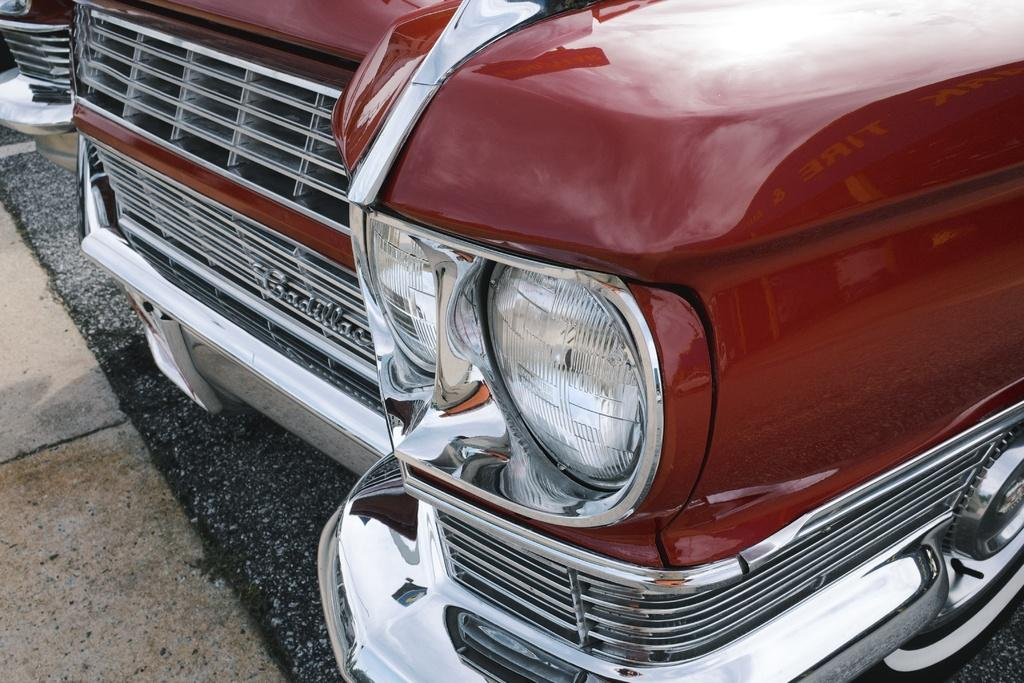What is the color of the vehicle in the image? The vehicle in the image is red. Where is the vehicle located in the image? The vehicle is on the road. What letter is written on the side of the vehicle in the image? There is no letter written on the side of the vehicle in the image. What type of hose is connected to the vehicle in the image? There is no hose connected to the vehicle in the image. 